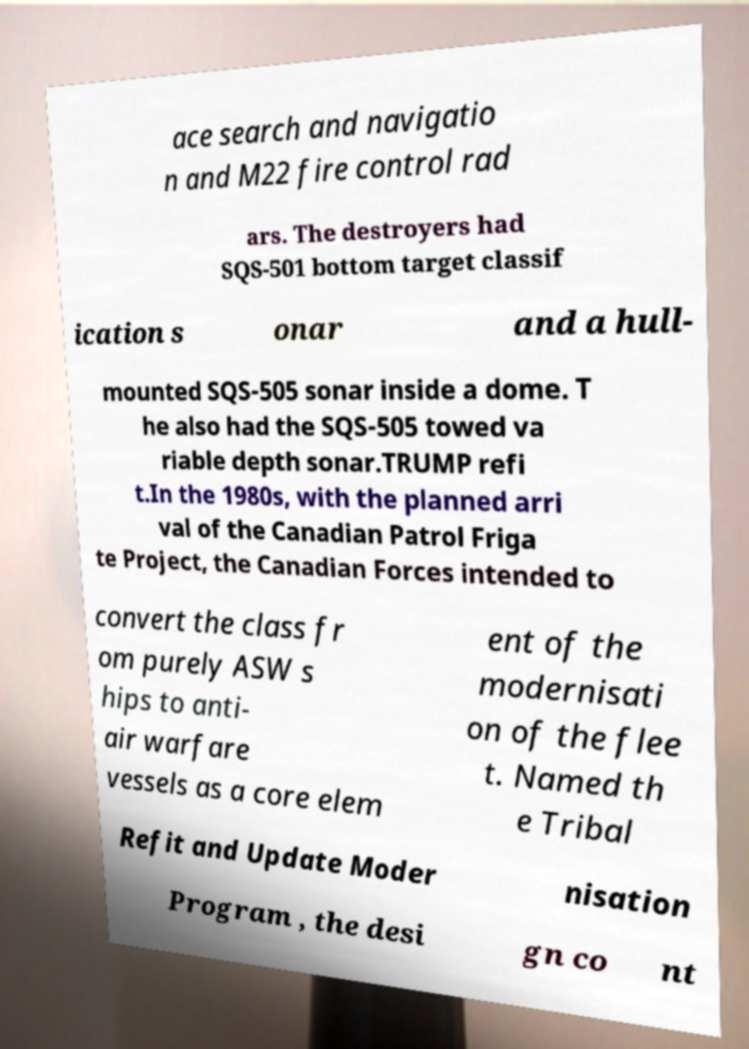There's text embedded in this image that I need extracted. Can you transcribe it verbatim? ace search and navigatio n and M22 fire control rad ars. The destroyers had SQS-501 bottom target classif ication s onar and a hull- mounted SQS-505 sonar inside a dome. T he also had the SQS-505 towed va riable depth sonar.TRUMP refi t.In the 1980s, with the planned arri val of the Canadian Patrol Friga te Project, the Canadian Forces intended to convert the class fr om purely ASW s hips to anti- air warfare vessels as a core elem ent of the modernisati on of the flee t. Named th e Tribal Refit and Update Moder nisation Program , the desi gn co nt 